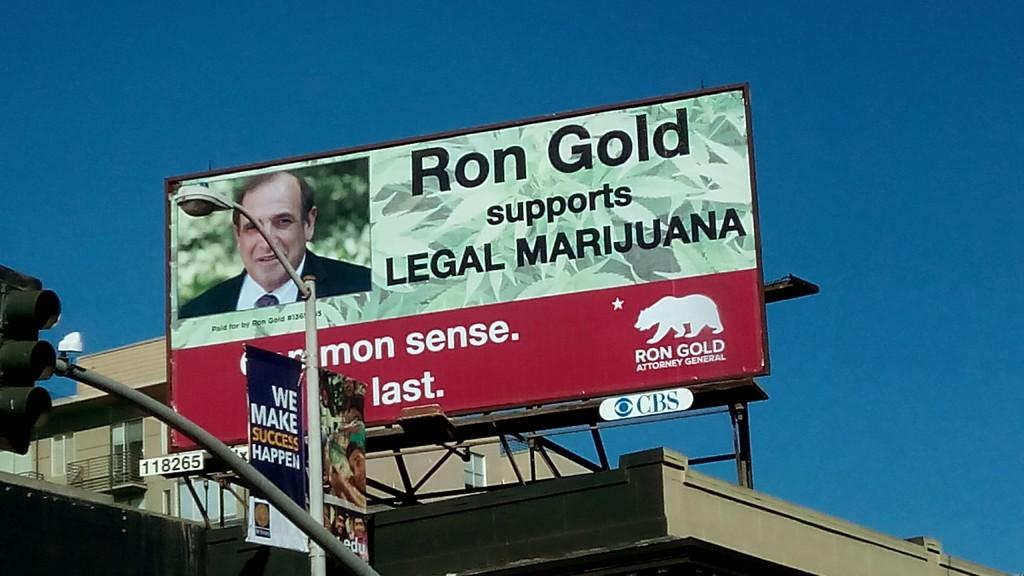<image>
Describe the image concisely. The man in the poster supports Legal Marijuana. 